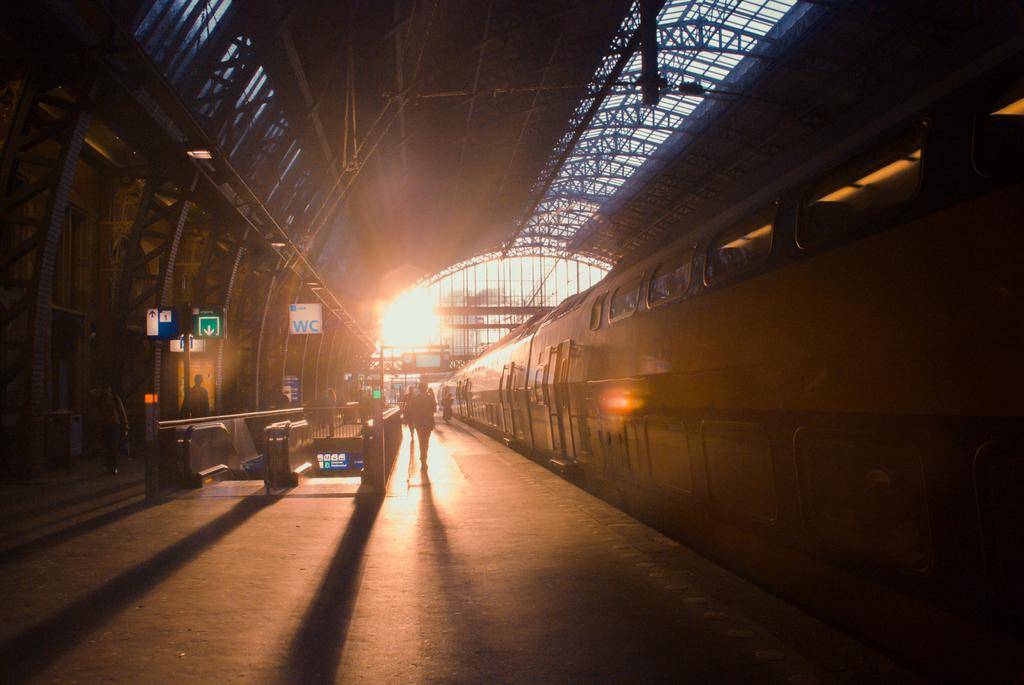<image>
Create a compact narrative representing the image presented. a train station with a white sign reading WC 